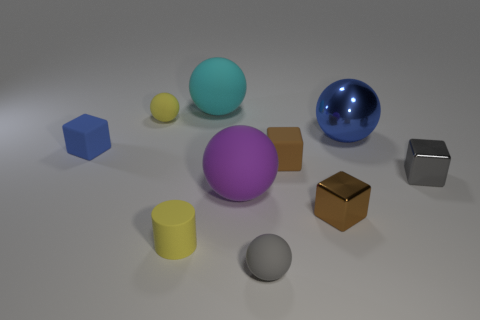What number of brown objects are left of the blue ball? There is one brown cube situated to the left of the blue ball. It's the only brown object in that area, positioned diagonally from the blue sphere. 